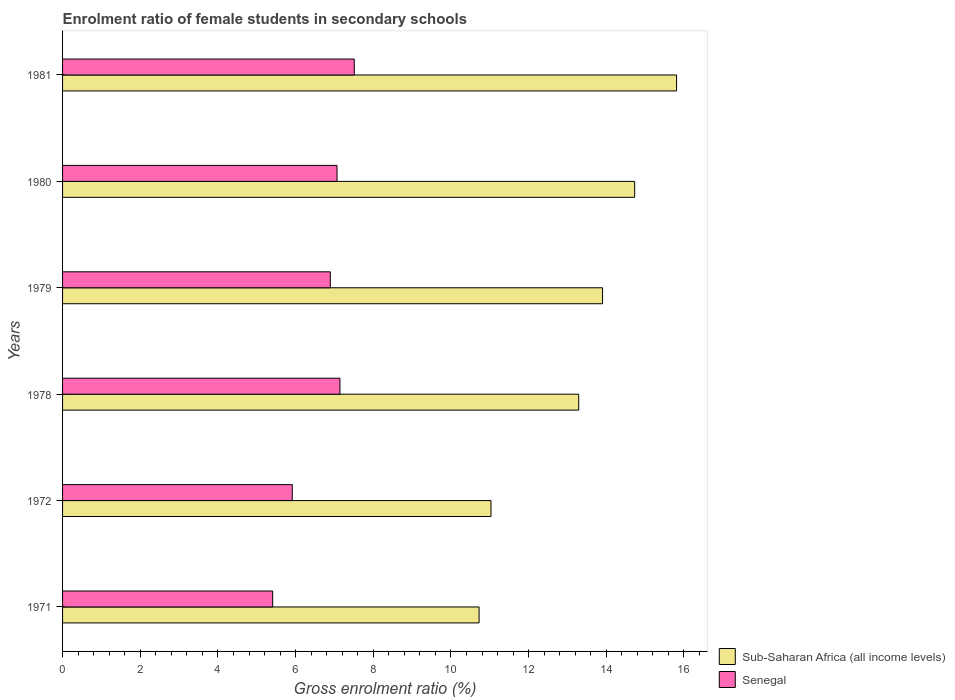How many different coloured bars are there?
Your answer should be very brief. 2. Are the number of bars per tick equal to the number of legend labels?
Provide a succinct answer. Yes. How many bars are there on the 2nd tick from the top?
Ensure brevity in your answer.  2. What is the label of the 4th group of bars from the top?
Your answer should be compact. 1978. What is the enrolment ratio of female students in secondary schools in Sub-Saharan Africa (all income levels) in 1980?
Make the answer very short. 14.73. Across all years, what is the maximum enrolment ratio of female students in secondary schools in Senegal?
Keep it short and to the point. 7.51. Across all years, what is the minimum enrolment ratio of female students in secondary schools in Senegal?
Ensure brevity in your answer.  5.41. What is the total enrolment ratio of female students in secondary schools in Senegal in the graph?
Keep it short and to the point. 39.94. What is the difference between the enrolment ratio of female students in secondary schools in Sub-Saharan Africa (all income levels) in 1979 and that in 1981?
Your response must be concise. -1.91. What is the difference between the enrolment ratio of female students in secondary schools in Sub-Saharan Africa (all income levels) in 1981 and the enrolment ratio of female students in secondary schools in Senegal in 1979?
Your answer should be very brief. 8.92. What is the average enrolment ratio of female students in secondary schools in Senegal per year?
Offer a very short reply. 6.66. In the year 1972, what is the difference between the enrolment ratio of female students in secondary schools in Senegal and enrolment ratio of female students in secondary schools in Sub-Saharan Africa (all income levels)?
Make the answer very short. -5.12. What is the ratio of the enrolment ratio of female students in secondary schools in Sub-Saharan Africa (all income levels) in 1972 to that in 1981?
Your response must be concise. 0.7. Is the difference between the enrolment ratio of female students in secondary schools in Senegal in 1972 and 1978 greater than the difference between the enrolment ratio of female students in secondary schools in Sub-Saharan Africa (all income levels) in 1972 and 1978?
Ensure brevity in your answer.  Yes. What is the difference between the highest and the second highest enrolment ratio of female students in secondary schools in Senegal?
Offer a very short reply. 0.37. What is the difference between the highest and the lowest enrolment ratio of female students in secondary schools in Senegal?
Keep it short and to the point. 2.1. In how many years, is the enrolment ratio of female students in secondary schools in Senegal greater than the average enrolment ratio of female students in secondary schools in Senegal taken over all years?
Keep it short and to the point. 4. What does the 2nd bar from the top in 1981 represents?
Your response must be concise. Sub-Saharan Africa (all income levels). What does the 2nd bar from the bottom in 1972 represents?
Offer a very short reply. Senegal. How many bars are there?
Provide a short and direct response. 12. Are all the bars in the graph horizontal?
Ensure brevity in your answer.  Yes. What is the difference between two consecutive major ticks on the X-axis?
Give a very brief answer. 2. Are the values on the major ticks of X-axis written in scientific E-notation?
Your answer should be compact. No. Does the graph contain any zero values?
Ensure brevity in your answer.  No. Does the graph contain grids?
Your answer should be compact. No. Where does the legend appear in the graph?
Offer a very short reply. Bottom right. How many legend labels are there?
Your answer should be compact. 2. How are the legend labels stacked?
Make the answer very short. Vertical. What is the title of the graph?
Make the answer very short. Enrolment ratio of female students in secondary schools. Does "St. Kitts and Nevis" appear as one of the legend labels in the graph?
Offer a very short reply. No. What is the label or title of the X-axis?
Provide a short and direct response. Gross enrolment ratio (%). What is the label or title of the Y-axis?
Provide a short and direct response. Years. What is the Gross enrolment ratio (%) in Sub-Saharan Africa (all income levels) in 1971?
Offer a very short reply. 10.72. What is the Gross enrolment ratio (%) in Senegal in 1971?
Offer a very short reply. 5.41. What is the Gross enrolment ratio (%) in Sub-Saharan Africa (all income levels) in 1972?
Provide a succinct answer. 11.03. What is the Gross enrolment ratio (%) of Senegal in 1972?
Your response must be concise. 5.91. What is the Gross enrolment ratio (%) in Sub-Saharan Africa (all income levels) in 1978?
Make the answer very short. 13.29. What is the Gross enrolment ratio (%) in Senegal in 1978?
Ensure brevity in your answer.  7.14. What is the Gross enrolment ratio (%) of Sub-Saharan Africa (all income levels) in 1979?
Make the answer very short. 13.9. What is the Gross enrolment ratio (%) in Senegal in 1979?
Your response must be concise. 6.89. What is the Gross enrolment ratio (%) in Sub-Saharan Africa (all income levels) in 1980?
Offer a very short reply. 14.73. What is the Gross enrolment ratio (%) of Senegal in 1980?
Ensure brevity in your answer.  7.07. What is the Gross enrolment ratio (%) in Sub-Saharan Africa (all income levels) in 1981?
Your answer should be very brief. 15.81. What is the Gross enrolment ratio (%) in Senegal in 1981?
Your answer should be very brief. 7.51. Across all years, what is the maximum Gross enrolment ratio (%) of Sub-Saharan Africa (all income levels)?
Make the answer very short. 15.81. Across all years, what is the maximum Gross enrolment ratio (%) of Senegal?
Your answer should be compact. 7.51. Across all years, what is the minimum Gross enrolment ratio (%) in Sub-Saharan Africa (all income levels)?
Give a very brief answer. 10.72. Across all years, what is the minimum Gross enrolment ratio (%) of Senegal?
Provide a succinct answer. 5.41. What is the total Gross enrolment ratio (%) of Sub-Saharan Africa (all income levels) in the graph?
Provide a short and direct response. 79.49. What is the total Gross enrolment ratio (%) of Senegal in the graph?
Provide a succinct answer. 39.94. What is the difference between the Gross enrolment ratio (%) of Sub-Saharan Africa (all income levels) in 1971 and that in 1972?
Your answer should be very brief. -0.31. What is the difference between the Gross enrolment ratio (%) in Senegal in 1971 and that in 1972?
Make the answer very short. -0.51. What is the difference between the Gross enrolment ratio (%) in Sub-Saharan Africa (all income levels) in 1971 and that in 1978?
Your response must be concise. -2.57. What is the difference between the Gross enrolment ratio (%) of Senegal in 1971 and that in 1978?
Offer a very short reply. -1.73. What is the difference between the Gross enrolment ratio (%) in Sub-Saharan Africa (all income levels) in 1971 and that in 1979?
Make the answer very short. -3.18. What is the difference between the Gross enrolment ratio (%) of Senegal in 1971 and that in 1979?
Provide a succinct answer. -1.48. What is the difference between the Gross enrolment ratio (%) in Sub-Saharan Africa (all income levels) in 1971 and that in 1980?
Offer a very short reply. -4.01. What is the difference between the Gross enrolment ratio (%) of Senegal in 1971 and that in 1980?
Make the answer very short. -1.66. What is the difference between the Gross enrolment ratio (%) in Sub-Saharan Africa (all income levels) in 1971 and that in 1981?
Provide a short and direct response. -5.08. What is the difference between the Gross enrolment ratio (%) of Senegal in 1971 and that in 1981?
Give a very brief answer. -2.1. What is the difference between the Gross enrolment ratio (%) in Sub-Saharan Africa (all income levels) in 1972 and that in 1978?
Make the answer very short. -2.26. What is the difference between the Gross enrolment ratio (%) in Senegal in 1972 and that in 1978?
Keep it short and to the point. -1.23. What is the difference between the Gross enrolment ratio (%) of Sub-Saharan Africa (all income levels) in 1972 and that in 1979?
Offer a terse response. -2.87. What is the difference between the Gross enrolment ratio (%) of Senegal in 1972 and that in 1979?
Offer a very short reply. -0.98. What is the difference between the Gross enrolment ratio (%) in Sub-Saharan Africa (all income levels) in 1972 and that in 1980?
Provide a succinct answer. -3.7. What is the difference between the Gross enrolment ratio (%) of Senegal in 1972 and that in 1980?
Keep it short and to the point. -1.15. What is the difference between the Gross enrolment ratio (%) of Sub-Saharan Africa (all income levels) in 1972 and that in 1981?
Provide a succinct answer. -4.78. What is the difference between the Gross enrolment ratio (%) of Senegal in 1972 and that in 1981?
Provide a short and direct response. -1.6. What is the difference between the Gross enrolment ratio (%) of Sub-Saharan Africa (all income levels) in 1978 and that in 1979?
Your answer should be compact. -0.61. What is the difference between the Gross enrolment ratio (%) in Senegal in 1978 and that in 1979?
Ensure brevity in your answer.  0.25. What is the difference between the Gross enrolment ratio (%) in Sub-Saharan Africa (all income levels) in 1978 and that in 1980?
Ensure brevity in your answer.  -1.44. What is the difference between the Gross enrolment ratio (%) of Senegal in 1978 and that in 1980?
Your response must be concise. 0.07. What is the difference between the Gross enrolment ratio (%) in Sub-Saharan Africa (all income levels) in 1978 and that in 1981?
Your answer should be very brief. -2.52. What is the difference between the Gross enrolment ratio (%) in Senegal in 1978 and that in 1981?
Make the answer very short. -0.37. What is the difference between the Gross enrolment ratio (%) in Sub-Saharan Africa (all income levels) in 1979 and that in 1980?
Keep it short and to the point. -0.83. What is the difference between the Gross enrolment ratio (%) in Senegal in 1979 and that in 1980?
Keep it short and to the point. -0.17. What is the difference between the Gross enrolment ratio (%) in Sub-Saharan Africa (all income levels) in 1979 and that in 1981?
Offer a very short reply. -1.91. What is the difference between the Gross enrolment ratio (%) of Senegal in 1979 and that in 1981?
Make the answer very short. -0.62. What is the difference between the Gross enrolment ratio (%) in Sub-Saharan Africa (all income levels) in 1980 and that in 1981?
Provide a short and direct response. -1.08. What is the difference between the Gross enrolment ratio (%) of Senegal in 1980 and that in 1981?
Your response must be concise. -0.44. What is the difference between the Gross enrolment ratio (%) of Sub-Saharan Africa (all income levels) in 1971 and the Gross enrolment ratio (%) of Senegal in 1972?
Your response must be concise. 4.81. What is the difference between the Gross enrolment ratio (%) of Sub-Saharan Africa (all income levels) in 1971 and the Gross enrolment ratio (%) of Senegal in 1978?
Keep it short and to the point. 3.58. What is the difference between the Gross enrolment ratio (%) of Sub-Saharan Africa (all income levels) in 1971 and the Gross enrolment ratio (%) of Senegal in 1979?
Offer a very short reply. 3.83. What is the difference between the Gross enrolment ratio (%) in Sub-Saharan Africa (all income levels) in 1971 and the Gross enrolment ratio (%) in Senegal in 1980?
Ensure brevity in your answer.  3.66. What is the difference between the Gross enrolment ratio (%) in Sub-Saharan Africa (all income levels) in 1971 and the Gross enrolment ratio (%) in Senegal in 1981?
Give a very brief answer. 3.21. What is the difference between the Gross enrolment ratio (%) of Sub-Saharan Africa (all income levels) in 1972 and the Gross enrolment ratio (%) of Senegal in 1978?
Your response must be concise. 3.89. What is the difference between the Gross enrolment ratio (%) in Sub-Saharan Africa (all income levels) in 1972 and the Gross enrolment ratio (%) in Senegal in 1979?
Provide a succinct answer. 4.14. What is the difference between the Gross enrolment ratio (%) in Sub-Saharan Africa (all income levels) in 1972 and the Gross enrolment ratio (%) in Senegal in 1980?
Your response must be concise. 3.96. What is the difference between the Gross enrolment ratio (%) in Sub-Saharan Africa (all income levels) in 1972 and the Gross enrolment ratio (%) in Senegal in 1981?
Make the answer very short. 3.52. What is the difference between the Gross enrolment ratio (%) of Sub-Saharan Africa (all income levels) in 1978 and the Gross enrolment ratio (%) of Senegal in 1979?
Your answer should be very brief. 6.4. What is the difference between the Gross enrolment ratio (%) of Sub-Saharan Africa (all income levels) in 1978 and the Gross enrolment ratio (%) of Senegal in 1980?
Ensure brevity in your answer.  6.22. What is the difference between the Gross enrolment ratio (%) of Sub-Saharan Africa (all income levels) in 1978 and the Gross enrolment ratio (%) of Senegal in 1981?
Provide a short and direct response. 5.78. What is the difference between the Gross enrolment ratio (%) in Sub-Saharan Africa (all income levels) in 1979 and the Gross enrolment ratio (%) in Senegal in 1980?
Offer a terse response. 6.84. What is the difference between the Gross enrolment ratio (%) of Sub-Saharan Africa (all income levels) in 1979 and the Gross enrolment ratio (%) of Senegal in 1981?
Your answer should be very brief. 6.39. What is the difference between the Gross enrolment ratio (%) of Sub-Saharan Africa (all income levels) in 1980 and the Gross enrolment ratio (%) of Senegal in 1981?
Your answer should be compact. 7.22. What is the average Gross enrolment ratio (%) in Sub-Saharan Africa (all income levels) per year?
Ensure brevity in your answer.  13.25. What is the average Gross enrolment ratio (%) in Senegal per year?
Give a very brief answer. 6.66. In the year 1971, what is the difference between the Gross enrolment ratio (%) in Sub-Saharan Africa (all income levels) and Gross enrolment ratio (%) in Senegal?
Your response must be concise. 5.31. In the year 1972, what is the difference between the Gross enrolment ratio (%) of Sub-Saharan Africa (all income levels) and Gross enrolment ratio (%) of Senegal?
Your response must be concise. 5.12. In the year 1978, what is the difference between the Gross enrolment ratio (%) in Sub-Saharan Africa (all income levels) and Gross enrolment ratio (%) in Senegal?
Your response must be concise. 6.15. In the year 1979, what is the difference between the Gross enrolment ratio (%) of Sub-Saharan Africa (all income levels) and Gross enrolment ratio (%) of Senegal?
Offer a very short reply. 7.01. In the year 1980, what is the difference between the Gross enrolment ratio (%) in Sub-Saharan Africa (all income levels) and Gross enrolment ratio (%) in Senegal?
Your answer should be compact. 7.66. In the year 1981, what is the difference between the Gross enrolment ratio (%) in Sub-Saharan Africa (all income levels) and Gross enrolment ratio (%) in Senegal?
Ensure brevity in your answer.  8.3. What is the ratio of the Gross enrolment ratio (%) of Sub-Saharan Africa (all income levels) in 1971 to that in 1972?
Offer a terse response. 0.97. What is the ratio of the Gross enrolment ratio (%) in Senegal in 1971 to that in 1972?
Ensure brevity in your answer.  0.91. What is the ratio of the Gross enrolment ratio (%) of Sub-Saharan Africa (all income levels) in 1971 to that in 1978?
Give a very brief answer. 0.81. What is the ratio of the Gross enrolment ratio (%) in Senegal in 1971 to that in 1978?
Offer a terse response. 0.76. What is the ratio of the Gross enrolment ratio (%) of Sub-Saharan Africa (all income levels) in 1971 to that in 1979?
Provide a short and direct response. 0.77. What is the ratio of the Gross enrolment ratio (%) in Senegal in 1971 to that in 1979?
Offer a terse response. 0.78. What is the ratio of the Gross enrolment ratio (%) of Sub-Saharan Africa (all income levels) in 1971 to that in 1980?
Keep it short and to the point. 0.73. What is the ratio of the Gross enrolment ratio (%) of Senegal in 1971 to that in 1980?
Keep it short and to the point. 0.77. What is the ratio of the Gross enrolment ratio (%) of Sub-Saharan Africa (all income levels) in 1971 to that in 1981?
Give a very brief answer. 0.68. What is the ratio of the Gross enrolment ratio (%) in Senegal in 1971 to that in 1981?
Offer a very short reply. 0.72. What is the ratio of the Gross enrolment ratio (%) of Sub-Saharan Africa (all income levels) in 1972 to that in 1978?
Your answer should be compact. 0.83. What is the ratio of the Gross enrolment ratio (%) in Senegal in 1972 to that in 1978?
Offer a very short reply. 0.83. What is the ratio of the Gross enrolment ratio (%) of Sub-Saharan Africa (all income levels) in 1972 to that in 1979?
Provide a short and direct response. 0.79. What is the ratio of the Gross enrolment ratio (%) in Senegal in 1972 to that in 1979?
Your response must be concise. 0.86. What is the ratio of the Gross enrolment ratio (%) of Sub-Saharan Africa (all income levels) in 1972 to that in 1980?
Your answer should be compact. 0.75. What is the ratio of the Gross enrolment ratio (%) in Senegal in 1972 to that in 1980?
Provide a short and direct response. 0.84. What is the ratio of the Gross enrolment ratio (%) in Sub-Saharan Africa (all income levels) in 1972 to that in 1981?
Offer a terse response. 0.7. What is the ratio of the Gross enrolment ratio (%) of Senegal in 1972 to that in 1981?
Ensure brevity in your answer.  0.79. What is the ratio of the Gross enrolment ratio (%) in Sub-Saharan Africa (all income levels) in 1978 to that in 1979?
Give a very brief answer. 0.96. What is the ratio of the Gross enrolment ratio (%) in Senegal in 1978 to that in 1979?
Offer a terse response. 1.04. What is the ratio of the Gross enrolment ratio (%) in Sub-Saharan Africa (all income levels) in 1978 to that in 1980?
Your answer should be compact. 0.9. What is the ratio of the Gross enrolment ratio (%) of Senegal in 1978 to that in 1980?
Your response must be concise. 1.01. What is the ratio of the Gross enrolment ratio (%) in Sub-Saharan Africa (all income levels) in 1978 to that in 1981?
Provide a succinct answer. 0.84. What is the ratio of the Gross enrolment ratio (%) of Senegal in 1978 to that in 1981?
Keep it short and to the point. 0.95. What is the ratio of the Gross enrolment ratio (%) in Sub-Saharan Africa (all income levels) in 1979 to that in 1980?
Ensure brevity in your answer.  0.94. What is the ratio of the Gross enrolment ratio (%) of Senegal in 1979 to that in 1980?
Offer a terse response. 0.98. What is the ratio of the Gross enrolment ratio (%) of Sub-Saharan Africa (all income levels) in 1979 to that in 1981?
Keep it short and to the point. 0.88. What is the ratio of the Gross enrolment ratio (%) of Senegal in 1979 to that in 1981?
Keep it short and to the point. 0.92. What is the ratio of the Gross enrolment ratio (%) of Sub-Saharan Africa (all income levels) in 1980 to that in 1981?
Ensure brevity in your answer.  0.93. What is the ratio of the Gross enrolment ratio (%) in Senegal in 1980 to that in 1981?
Your answer should be very brief. 0.94. What is the difference between the highest and the second highest Gross enrolment ratio (%) of Sub-Saharan Africa (all income levels)?
Your response must be concise. 1.08. What is the difference between the highest and the second highest Gross enrolment ratio (%) in Senegal?
Your answer should be compact. 0.37. What is the difference between the highest and the lowest Gross enrolment ratio (%) in Sub-Saharan Africa (all income levels)?
Provide a short and direct response. 5.08. What is the difference between the highest and the lowest Gross enrolment ratio (%) of Senegal?
Your answer should be compact. 2.1. 